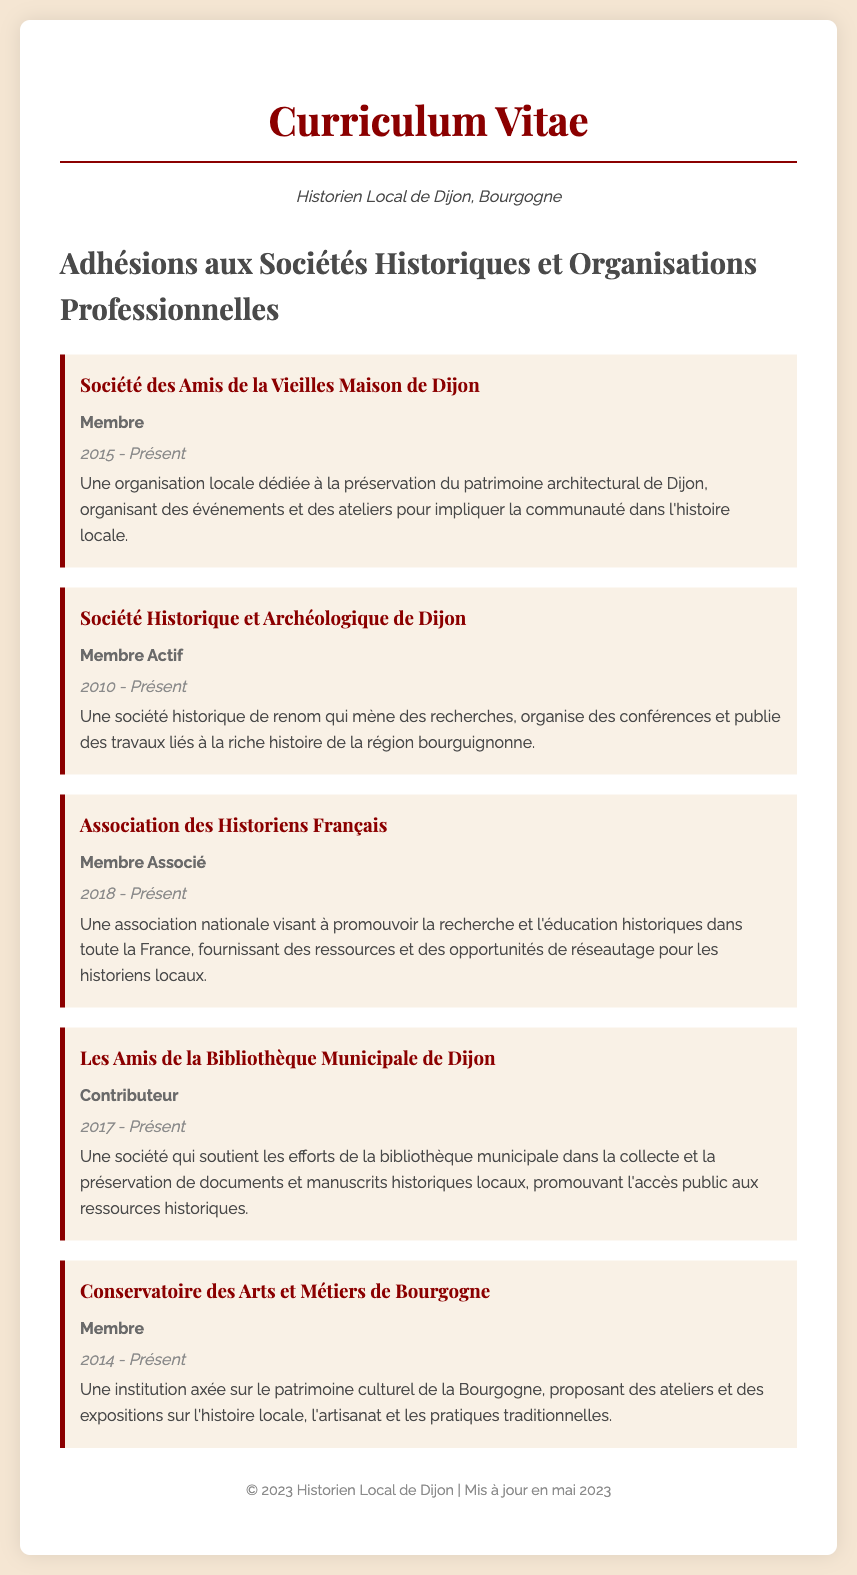What is the name of the organization focused on the preservation of architectural heritage in Dijon? The document lists "Société des Amis de la Vieilles Maison de Dijon" as the organization dedicated to this cause.
Answer: Société des Amis de la Vieilles Maison de Dijon What is the role of the applicant in the Société Historique et Archéologique de Dijon? The document indicates that the applicant is an "Membre Actif" in this organization.
Answer: Membre Actif From what year has the applicant been a member of the Association des Historiens Français? The applicant joined the Association des Historiens Français in 2018, as stated in the document.
Answer: 2018 How many organizations is the applicant currently a member of? The document lists five organizations, indicating the applicant's involvement in all of them.
Answer: 5 What is the primary focus of the Conservatoire des Arts et Métiers de Bourgogne? The document describes this institution as focused on the cultural heritage of Burgundy.
Answer: Patrimoine culturel de la Bourgogne Which organization is dedicated to supporting the municipal library's collection efforts? The document specifies "Les Amis de la Bibliothèque Municipale de Dijon" as the organization that supports these efforts.
Answer: Les Amis de la Bibliothèque Municipale de Dijon When was the Société des Amis de la Vieilles Maison de Dijon established? The document does not specify the founding year, only that the applicant has been a member since 2015.
Answer: N/A What type of events does the Société Historique et Archéologique de Dijon organize? The organization is noted for organizing conferences related to the history of the Burgundy region.
Answer: Conférences What position does the applicant hold in the Les Amis de la Bibliothèque Municipale de Dijon? According to the document, the applicant's role is listed as "Contributeur."
Answer: Contributeur 